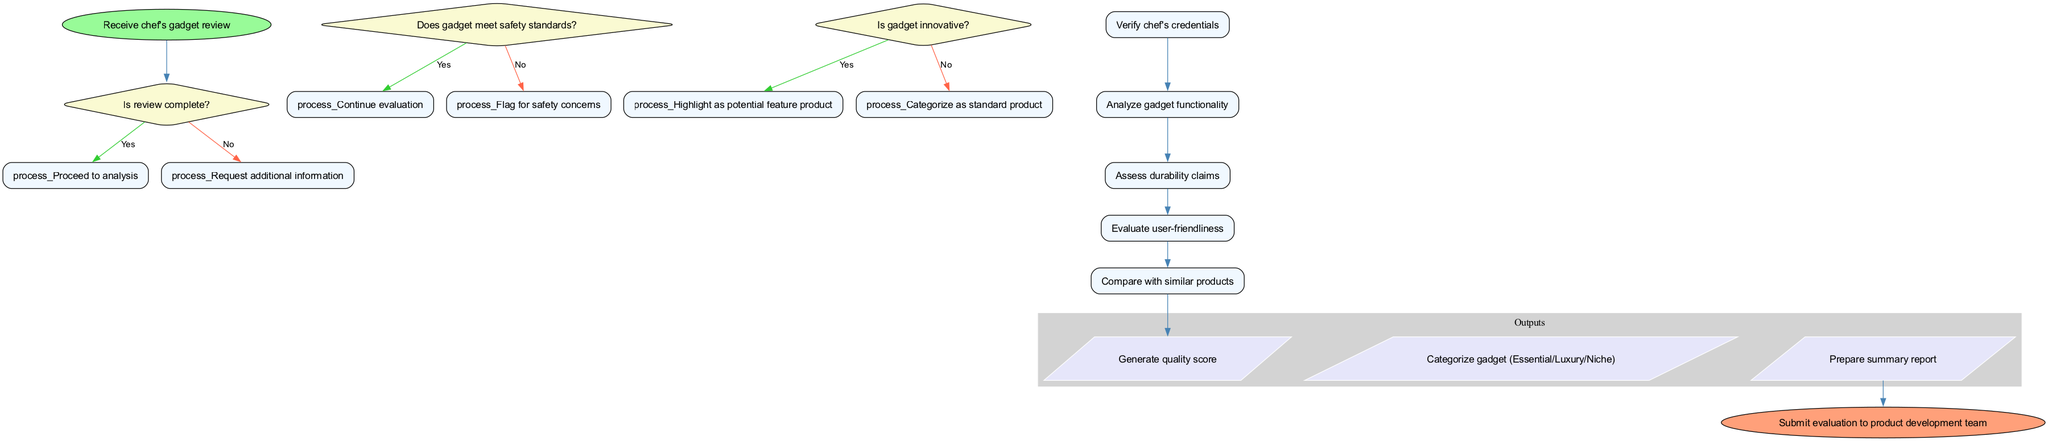What is the first step in the workflow? The first step in the workflow diagram is to "Receive chef's gadget review," which is indicated by the start node that initiates the flow.
Answer: Receive chef's gadget review How many decision nodes are present in the diagram? The diagram lists three decision nodes that outline conditions regarding review completeness, safety standards, and innovation level of the gadget.
Answer: Three What happens if the review is not complete? If the review is not complete, the workflow specifies that it will "Request additional information," based on the flow from the first decision node.
Answer: Request additional information What is the last step before submission to the product development team? The last step before submission to the product development team involves generating a summary report, as it is the final output in the workflow diagram.
Answer: Prepare summary report What condition must be checked after verifying the chef's credentials? After verifying the chef's credentials, the next condition that must be checked is whether the gadget meets safety standards as per the flow layout.
Answer: Does gadget meet safety standards? If a gadget is flagged for safety concerns, what would be the next step? If a gadget is flagged for safety concerns, the workflow does not specify any further processes related to this flagging, implying it results in a halt in the evaluation process.
Answer: Evaluation halted Which process follows after analyzing gadget functionality? After analyzing gadget functionality, the next process that follows in sequence is assessing durability claims, continuing the evaluation of the gadget's attributes.
Answer: Assess durability claims What happens if a gadget is categorized as standard product? If a gadget is categorized as a standard product, it does not influence any major outputs in the workflow like highlighting it as a potential feature product; it simply moves to standard categorization.
Answer: Categorize as standard product 